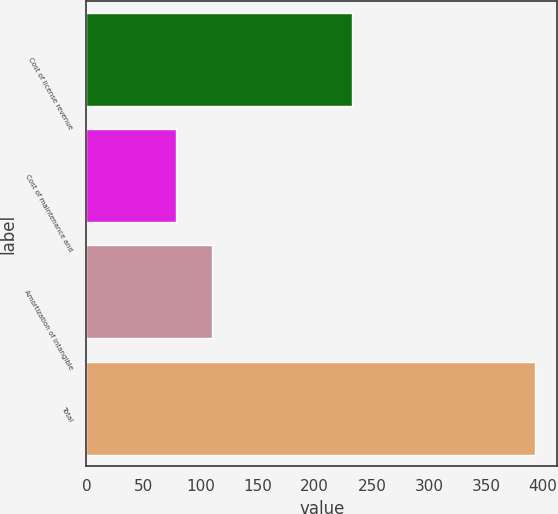Convert chart. <chart><loc_0><loc_0><loc_500><loc_500><bar_chart><fcel>Cost of license revenue<fcel>Cost of maintenance and<fcel>Amortization of intangible<fcel>Total<nl><fcel>232.8<fcel>78.6<fcel>110.01<fcel>392.7<nl></chart> 